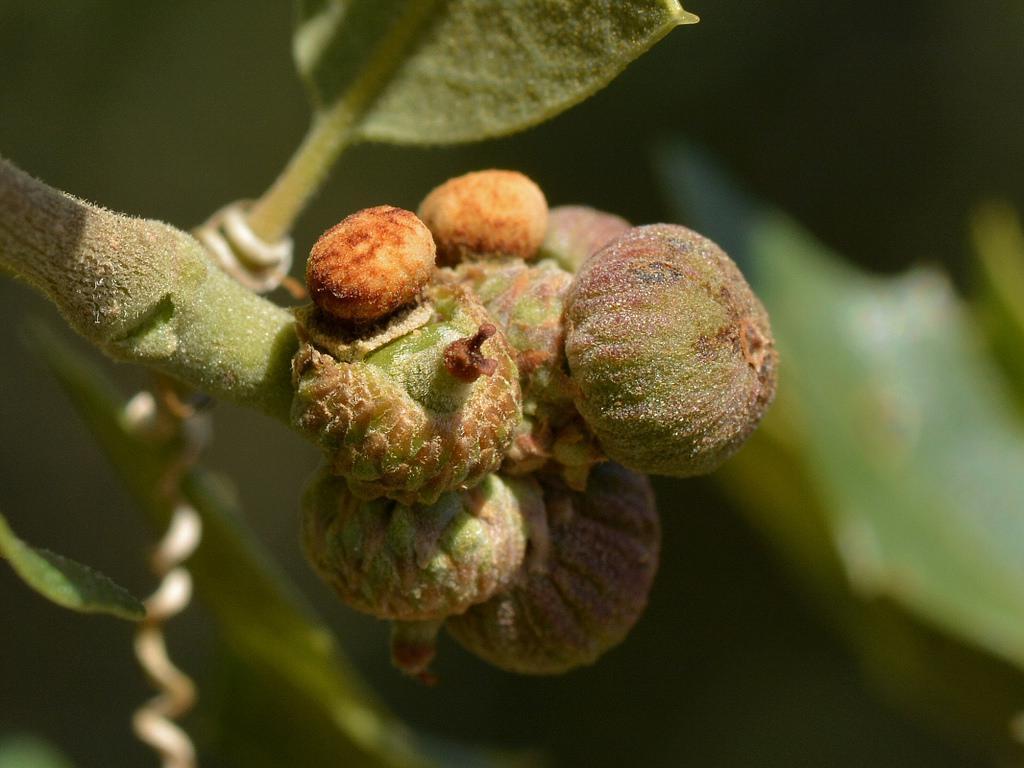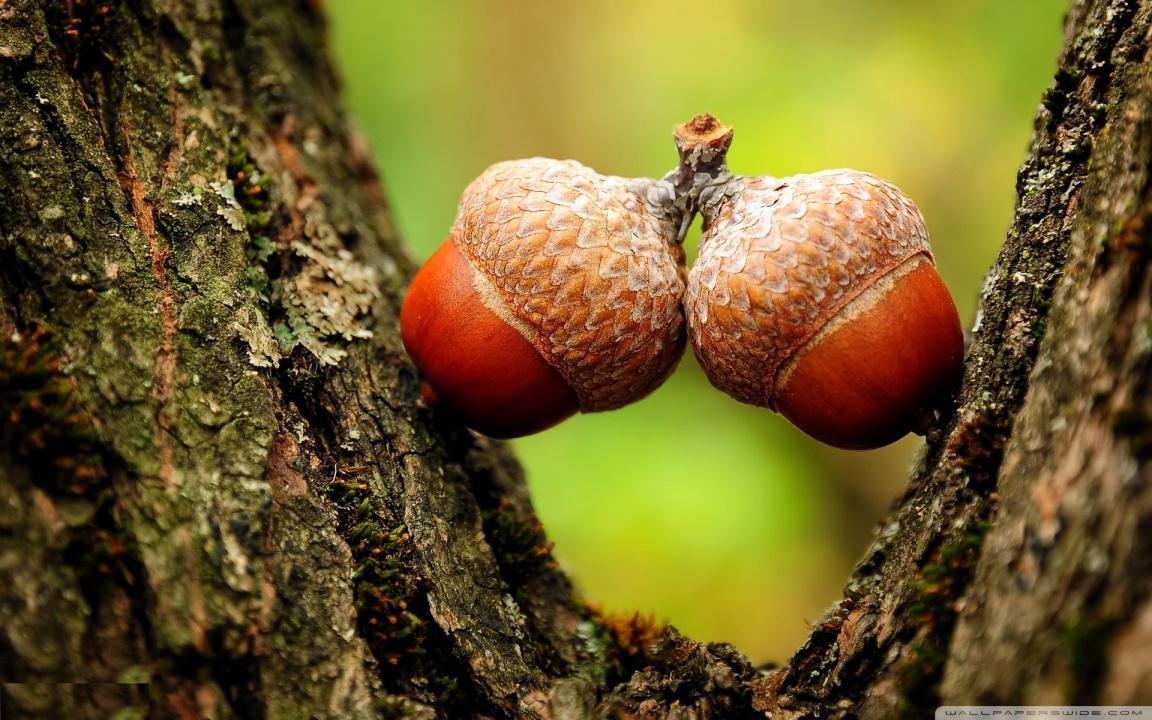The first image is the image on the left, the second image is the image on the right. Evaluate the accuracy of this statement regarding the images: "There are two green acorns and green acorn tops still attach to there branch.". Is it true? Answer yes or no. No. The first image is the image on the left, the second image is the image on the right. Assess this claim about the two images: "One image includes at least one brown acorn, and the other image features acorns that haven't fully emerged from their caps.". Correct or not? Answer yes or no. Yes. 